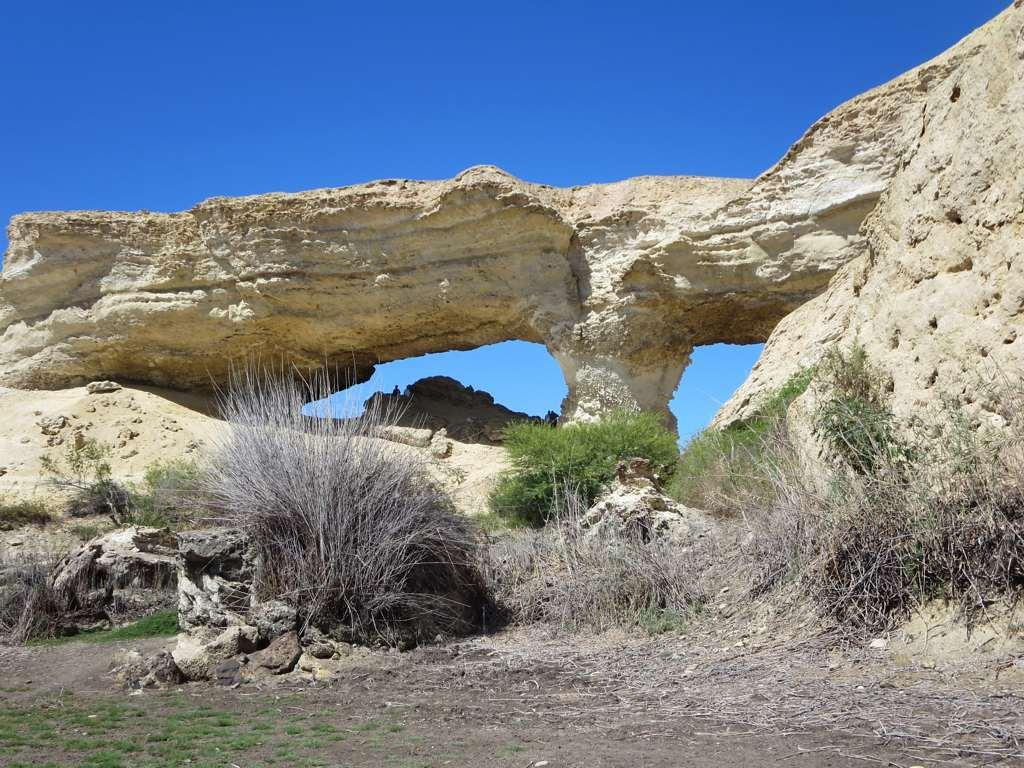What type of natural elements can be seen in the image? There are big stones and grass in the image. Can you describe the condition of the grass in the image? There is both grass and dry grass visible in the image. What color is the sky in the image? The sky is blue in the image. How much sugar is sprinkled on the notebook in the image? There is no notebook or sugar present in the image. What type of hair can be seen on the big stones in the image? There is no hair visible on the big stones in the image. 